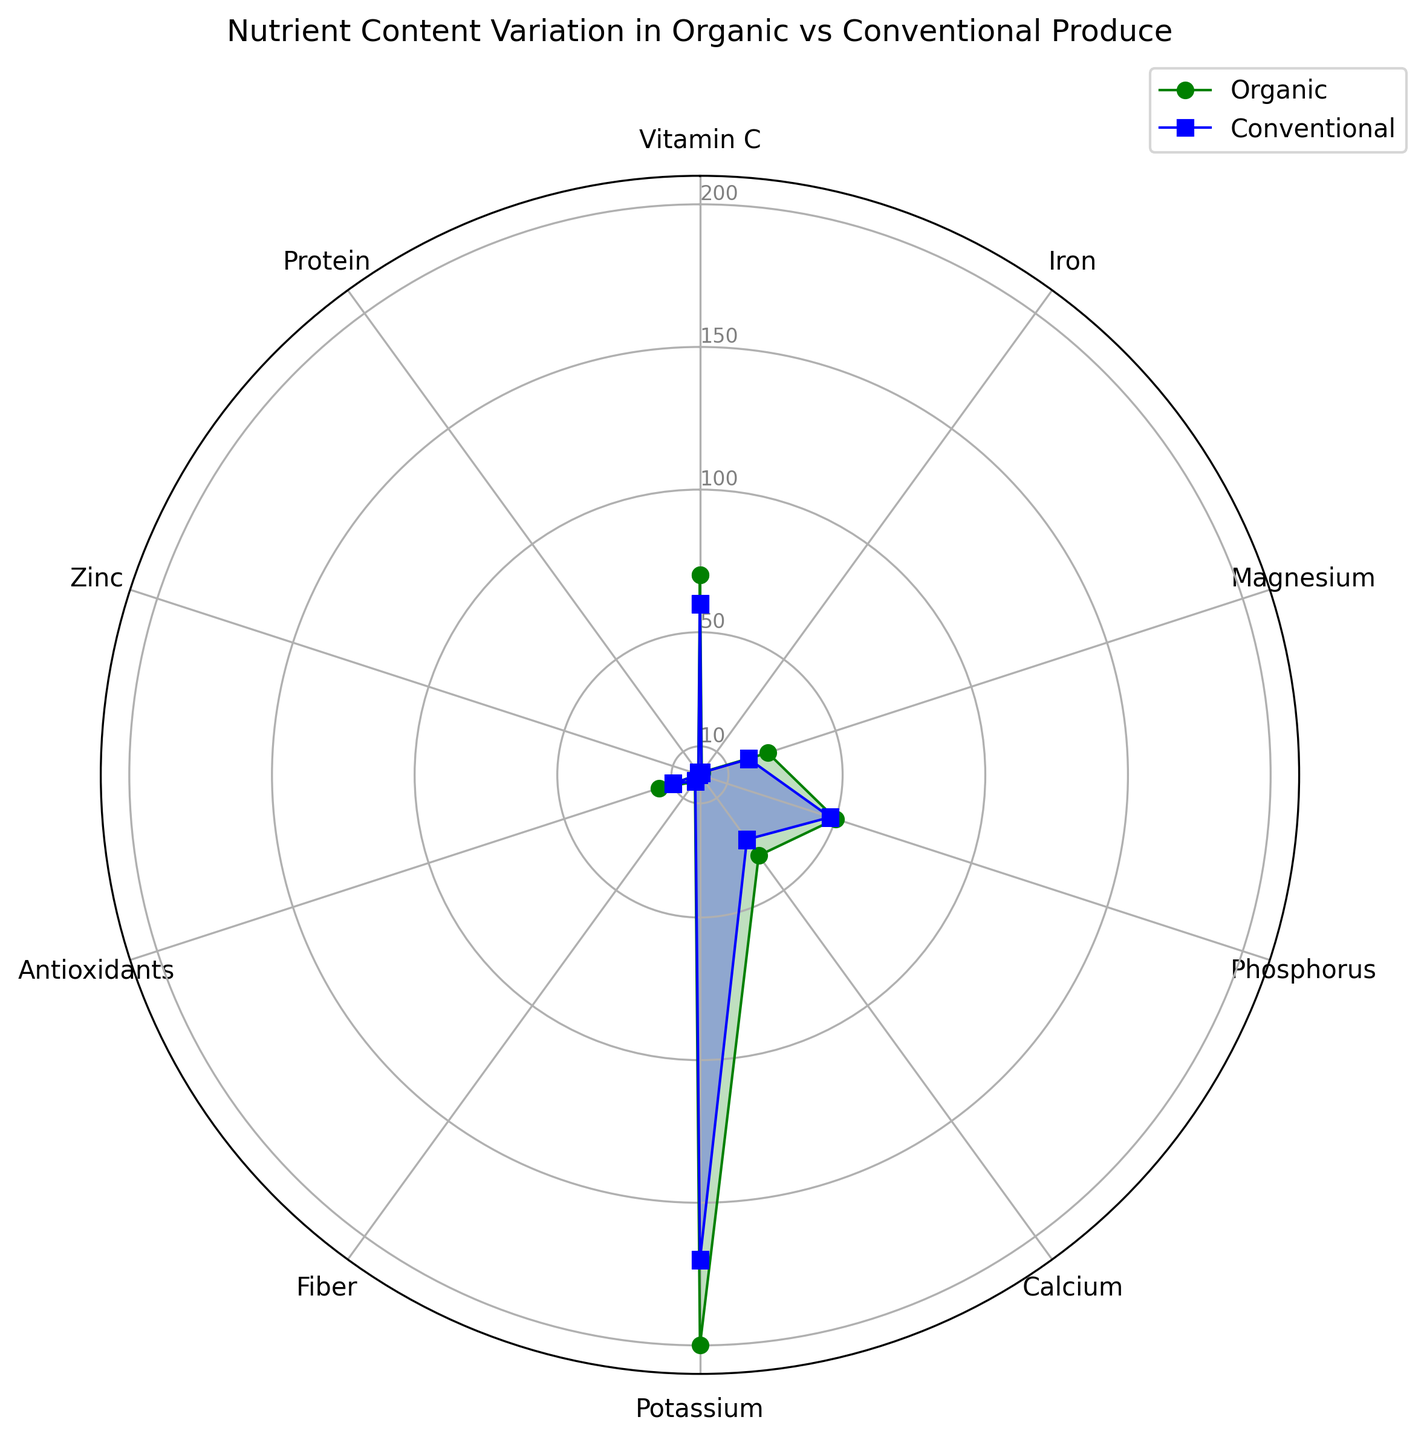What's the highest nutrient content found in Organic produce? To find the highest nutrient content, check the data values represented by the green area. The maximum value for Organic produce in the chart seems to be Potassium with 200 units.
Answer: Potassium Which nutrient shows the smallest difference between Organic and Conventional produce? The difference between nutrient values for Organic and Conventional produce can be calculated for each nutrient. The smallest difference found is for Phosphorus, which is 50 - 48 = 2 units.
Answer: Phosphorus Is the Vitamin C content higher in Organic or Conventional produce? By comparing the height of the green and blue data points on the Vitamin C axis, we see that the green point (Organic) is higher than the blue point (Conventional). Thus, Organic produce has a higher Vitamin C content (70 vs. 60 units).
Answer: Organic What is the ratio of Zinc content between Organic and Conventional produce? To calculate the ratio, divide the Zinc content in Organic produce by the Zinc content in Conventional produce (0.4 / 0.3). The ratio is about 1.33.
Answer: 1.33 What’s the average content of Fiber in Organic and Conventional produce? To find the average, add the Fiber content values for Organic and Conventional produce and divide by 2. (3 + 2.8) / 2 = 2.9 units on average.
Answer: 2.9 Which type of produce, Organic or Conventional, has a higher Iron content? By visually comparing the Iron axis, we can see the green point (Organic) is higher than the blue point (Conventional), indicating that Organic produce has a higher Iron content (1.1 vs. 0.9 units).
Answer: Organic When comparing Antioxidant content, by how many units is Organic produce superior to Conventional produce? Find the difference by subtracting the Antioxidant content of Conventional from Organic (15 - 10). The result is 5 units.
Answer: 5 units What's the difference in Protein content between Organic and Conventional produce? Subtract the Protein content of Conventional from that of Organic (1 - 0.9). The result is 0.1 units.
Answer: 0.1 units How does the Calcium content in Organic produce compare to that in Conventional produce in terms of percentage increase? To calculate the percentage increase, use the formula [(Organic - Conventional) / Conventional] * 100. For Calcium, it’s [(35 - 28) / 28] * 100 ≈ 25%.
Answer: 25% 